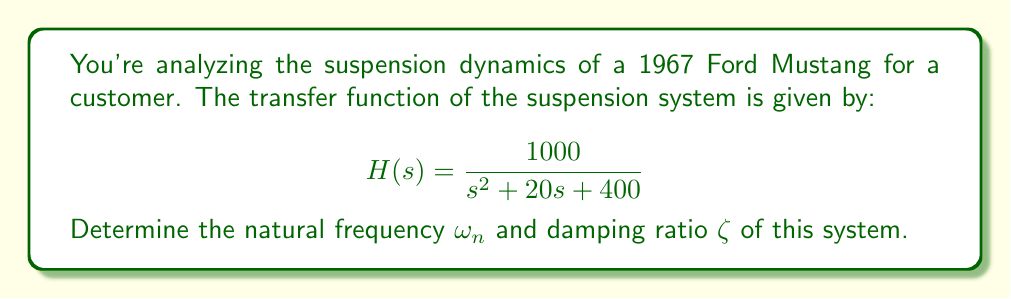Can you solve this math problem? To find the natural frequency $\omega_n$ and damping ratio $\zeta$, we need to compare the given transfer function to the standard form of a second-order system:

$$H(s) = \frac{\omega_n^2}{s^2 + 2\zeta\omega_n s + \omega_n^2}$$

Step 1: Identify the coefficients in the denominator of the given transfer function:
$s^2 + 20s + 400$

Step 2: Compare these coefficients with the standard form:
$20 = 2\zeta\omega_n$
$400 = \omega_n^2$

Step 3: Calculate the natural frequency $\omega_n$:
$\omega_n = \sqrt{400} = 20$ rad/s

Step 4: Calculate the damping ratio $\zeta$:
$\zeta = \frac{20}{2\omega_n} = \frac{20}{2(20)} = 0.5$

Therefore, the natural frequency is 20 rad/s, and the damping ratio is 0.5.
Answer: $\omega_n = 20$ rad/s, $\zeta = 0.5$ 